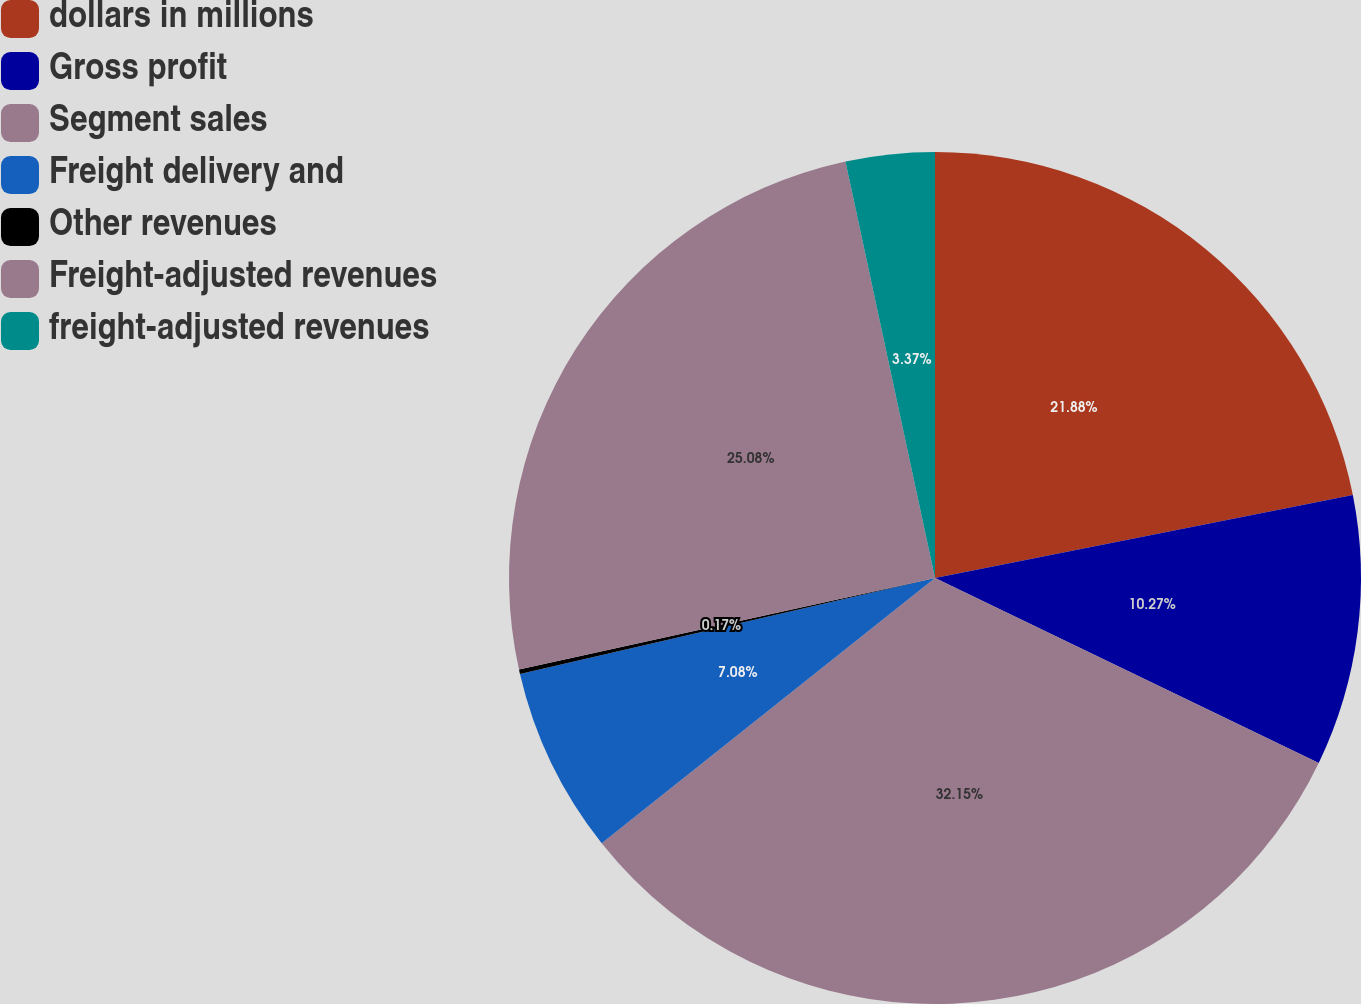Convert chart to OTSL. <chart><loc_0><loc_0><loc_500><loc_500><pie_chart><fcel>dollars in millions<fcel>Gross profit<fcel>Segment sales<fcel>Freight delivery and<fcel>Other revenues<fcel>Freight-adjusted revenues<fcel>freight-adjusted revenues<nl><fcel>21.88%<fcel>10.27%<fcel>32.15%<fcel>7.08%<fcel>0.17%<fcel>25.08%<fcel>3.37%<nl></chart> 